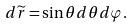Convert formula to latex. <formula><loc_0><loc_0><loc_500><loc_500>d \widetilde { r } = \sin \theta d \theta d \varphi .</formula> 